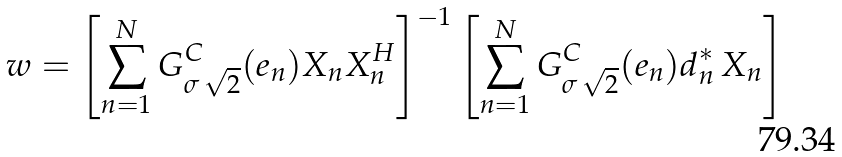Convert formula to latex. <formula><loc_0><loc_0><loc_500><loc_500>w = \left [ \sum _ { n = 1 } ^ { N } G ^ { C } _ { \sigma \, \sqrt { 2 } } ( e _ { n } ) X _ { n } X _ { n } ^ { H } \right ] ^ { - 1 } \left [ \sum _ { n = 1 } ^ { N } G ^ { C } _ { \sigma \, \sqrt { 2 } } ( e _ { n } ) d _ { n } ^ { * } \, X _ { n } \right ]</formula> 